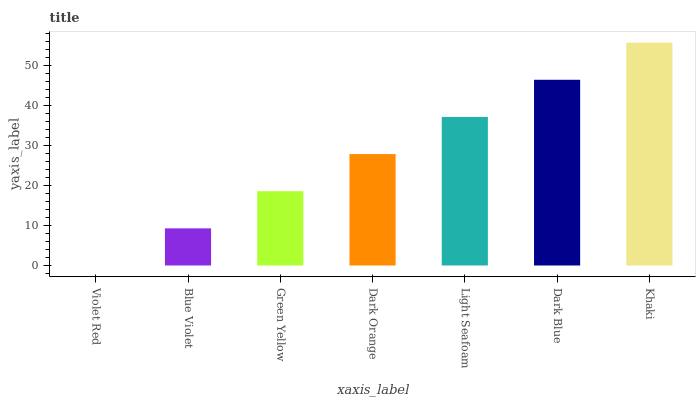Is Violet Red the minimum?
Answer yes or no. Yes. Is Khaki the maximum?
Answer yes or no. Yes. Is Blue Violet the minimum?
Answer yes or no. No. Is Blue Violet the maximum?
Answer yes or no. No. Is Blue Violet greater than Violet Red?
Answer yes or no. Yes. Is Violet Red less than Blue Violet?
Answer yes or no. Yes. Is Violet Red greater than Blue Violet?
Answer yes or no. No. Is Blue Violet less than Violet Red?
Answer yes or no. No. Is Dark Orange the high median?
Answer yes or no. Yes. Is Dark Orange the low median?
Answer yes or no. Yes. Is Violet Red the high median?
Answer yes or no. No. Is Light Seafoam the low median?
Answer yes or no. No. 